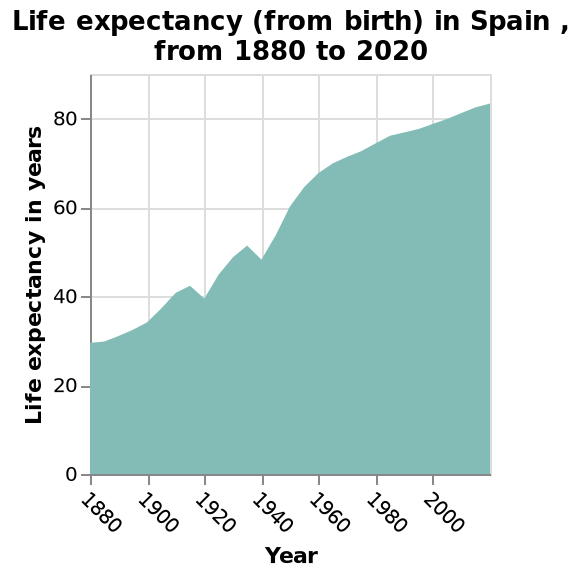<image>
How often did the life expectancy in Spain increase before 1960?  The life expectancy in Spain rose every year before 1960, except for the dips in 1920 and 1940. What does the x-axis represent? The x-axis represents the years from 1880 to 2020. 